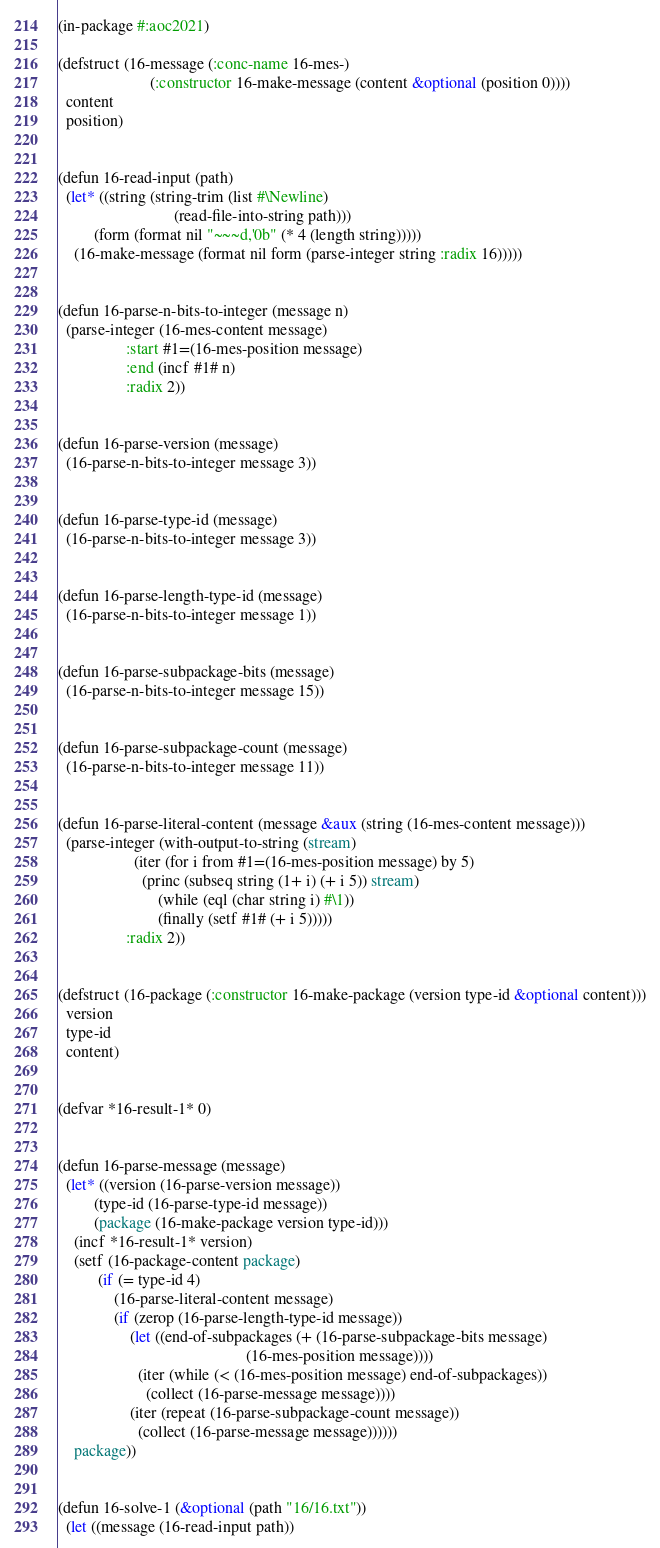Convert code to text. <code><loc_0><loc_0><loc_500><loc_500><_Lisp_>(in-package #:aoc2021)

(defstruct (16-message (:conc-name 16-mes-)
                       (:constructor 16-make-message (content &optional (position 0))))
  content
  position)


(defun 16-read-input (path)
  (let* ((string (string-trim (list #\Newline)
                             (read-file-into-string path)))
         (form (format nil "~~~d,'0b" (* 4 (length string)))))
    (16-make-message (format nil form (parse-integer string :radix 16)))))


(defun 16-parse-n-bits-to-integer (message n)
  (parse-integer (16-mes-content message)
                 :start #1=(16-mes-position message)
                 :end (incf #1# n)
                 :radix 2))


(defun 16-parse-version (message)
  (16-parse-n-bits-to-integer message 3))


(defun 16-parse-type-id (message)
  (16-parse-n-bits-to-integer message 3))


(defun 16-parse-length-type-id (message)
  (16-parse-n-bits-to-integer message 1))


(defun 16-parse-subpackage-bits (message)
  (16-parse-n-bits-to-integer message 15))


(defun 16-parse-subpackage-count (message)
  (16-parse-n-bits-to-integer message 11))


(defun 16-parse-literal-content (message &aux (string (16-mes-content message)))
  (parse-integer (with-output-to-string (stream)
                   (iter (for i from #1=(16-mes-position message) by 5)
                     (princ (subseq string (1+ i) (+ i 5)) stream)
                         (while (eql (char string i) #\1))
                         (finally (setf #1# (+ i 5)))))
                 :radix 2))


(defstruct (16-package (:constructor 16-make-package (version type-id &optional content)))
  version
  type-id
  content)


(defvar *16-result-1* 0)


(defun 16-parse-message (message)
  (let* ((version (16-parse-version message))
         (type-id (16-parse-type-id message))
         (package (16-make-package version type-id)))
    (incf *16-result-1* version)
    (setf (16-package-content package)
          (if (= type-id 4)
              (16-parse-literal-content message)
              (if (zerop (16-parse-length-type-id message))
                  (let ((end-of-subpackages (+ (16-parse-subpackage-bits message)
                                               (16-mes-position message))))
                    (iter (while (< (16-mes-position message) end-of-subpackages))
                      (collect (16-parse-message message))))
                  (iter (repeat (16-parse-subpackage-count message))
                    (collect (16-parse-message message))))))
    package))


(defun 16-solve-1 (&optional (path "16/16.txt"))
  (let ((message (16-read-input path))</code> 